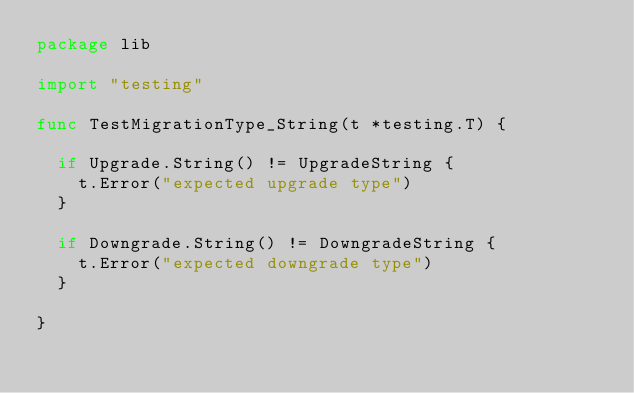Convert code to text. <code><loc_0><loc_0><loc_500><loc_500><_Go_>package lib

import "testing"

func TestMigrationType_String(t *testing.T) {

	if Upgrade.String() != UpgradeString {
		t.Error("expected upgrade type")
	}

	if Downgrade.String() != DowngradeString {
		t.Error("expected downgrade type")
	}

}
</code> 